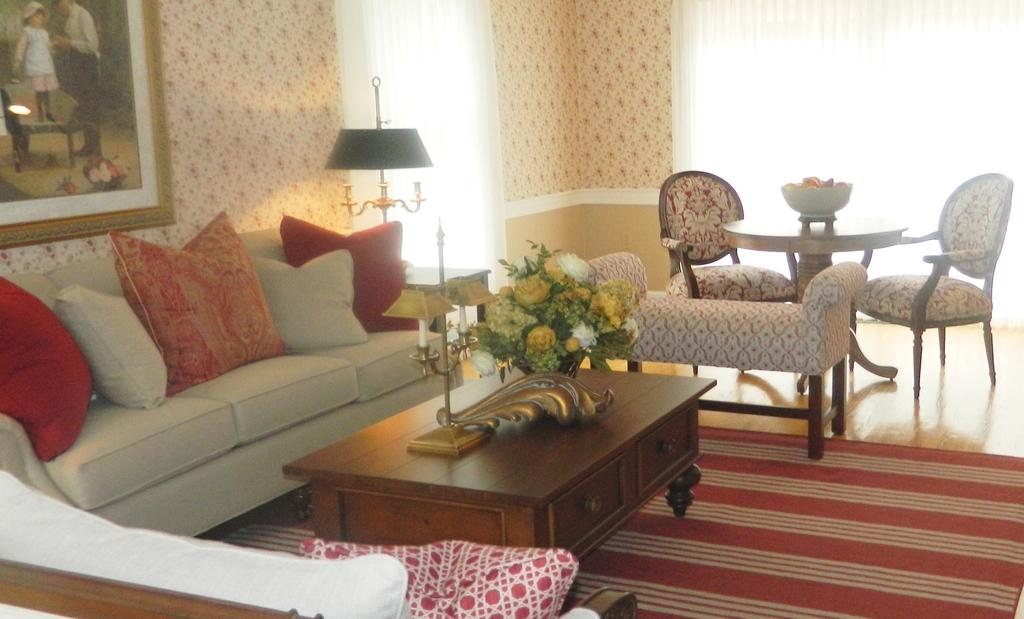What type of furniture is located on the left side of the image? There is a sofa on the left side of the image. What is in the middle of the image? There is a table in the middle of the image. What type of furniture is on the right side of the image? There are chairs on the right side of the image. What is on the floor in the image? There is a mat on the floor. What type of vegetable is being used as a drum in the image? There is no vegetable or drum present in the image. Can you tell me where the mother is sitting in the image? There is no mention of a mother or any person sitting in the image. 